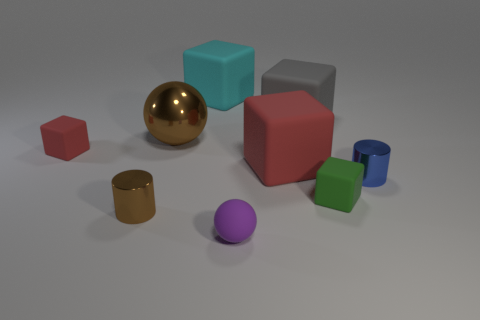Subtract all small red rubber cubes. How many cubes are left? 4 Subtract 1 spheres. How many spheres are left? 1 Add 1 cyan cylinders. How many objects exist? 10 Subtract all spheres. How many objects are left? 7 Subtract all red blocks. How many blocks are left? 3 Subtract all red cylinders. Subtract all brown spheres. How many cylinders are left? 2 Subtract all cyan spheres. How many green cylinders are left? 0 Subtract all big blocks. Subtract all large objects. How many objects are left? 2 Add 1 shiny cylinders. How many shiny cylinders are left? 3 Add 4 purple metal cylinders. How many purple metal cylinders exist? 4 